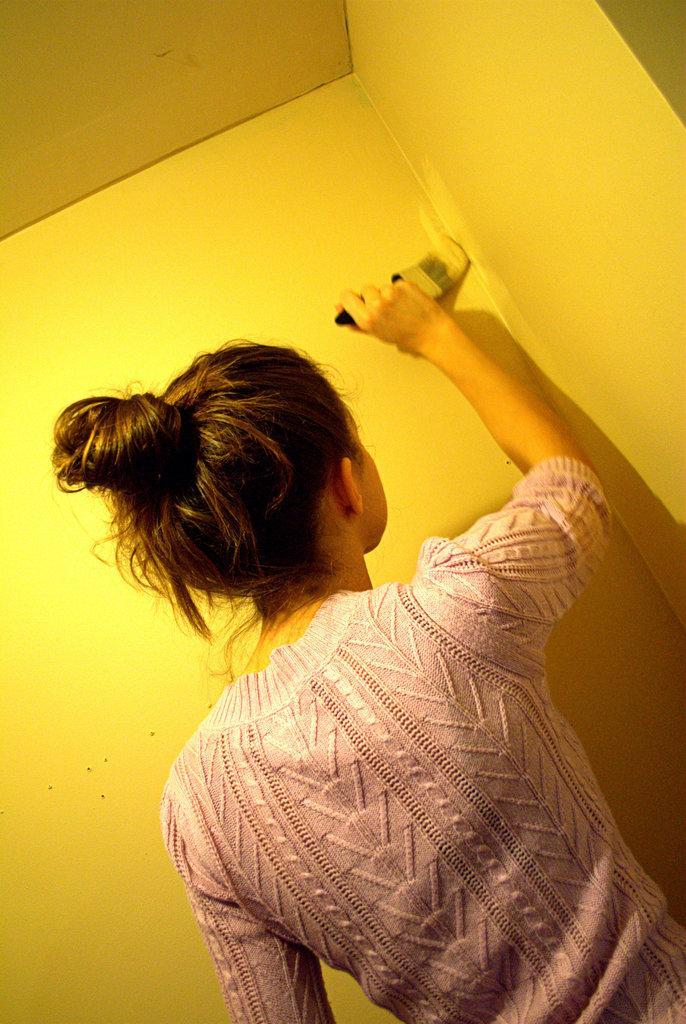How would you summarize this image in a sentence or two? There is a lady painting a wall with a brush. In the background there is yellow wall. 